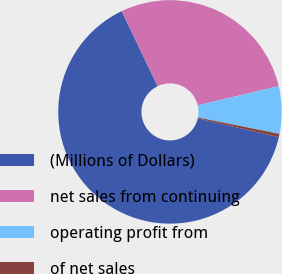Convert chart. <chart><loc_0><loc_0><loc_500><loc_500><pie_chart><fcel>(Millions of Dollars)<fcel>net sales from continuing<fcel>operating profit from<fcel>of net sales<nl><fcel>64.25%<fcel>28.41%<fcel>6.86%<fcel>0.48%<nl></chart> 